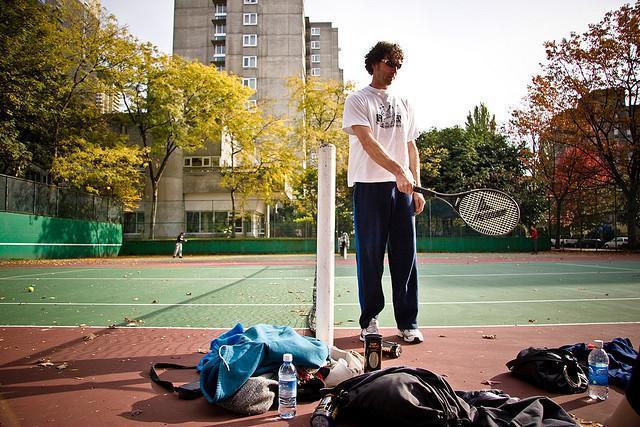How many bottles of water are in the picture?
Give a very brief answer. 2. How many backpacks can be seen?
Give a very brief answer. 2. How many baby sheep are there in the center of the photo beneath the adult sheep?
Give a very brief answer. 0. 